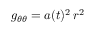<formula> <loc_0><loc_0><loc_500><loc_500>g _ { \theta \theta } = a ( t ) ^ { 2 } \, r ^ { 2 }</formula> 